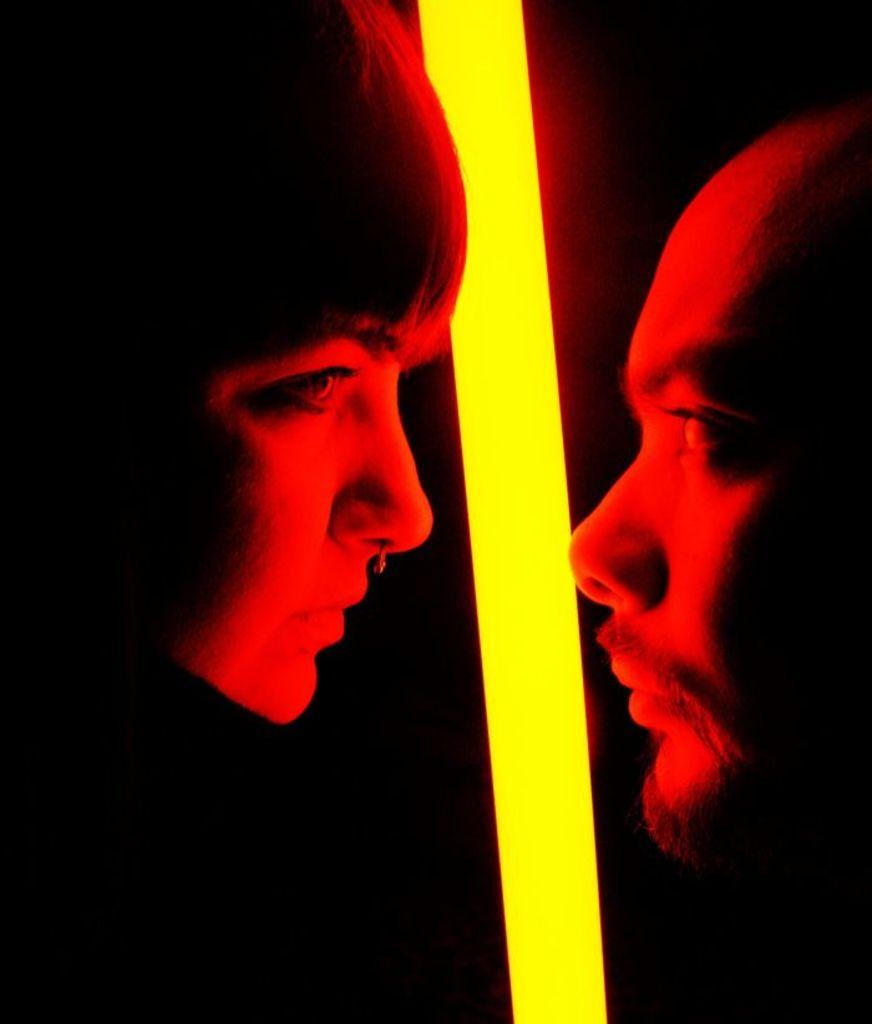What can be seen in the image? There is a man's face and a woman's face in the image. What else is present in the image? There is a light present in the image. What type of wire can be seen on the man's face in the image? There is no wire present on the man's face in the image. What season is depicted in the image? The image does not depict a specific season, as there are no seasonal cues present. 